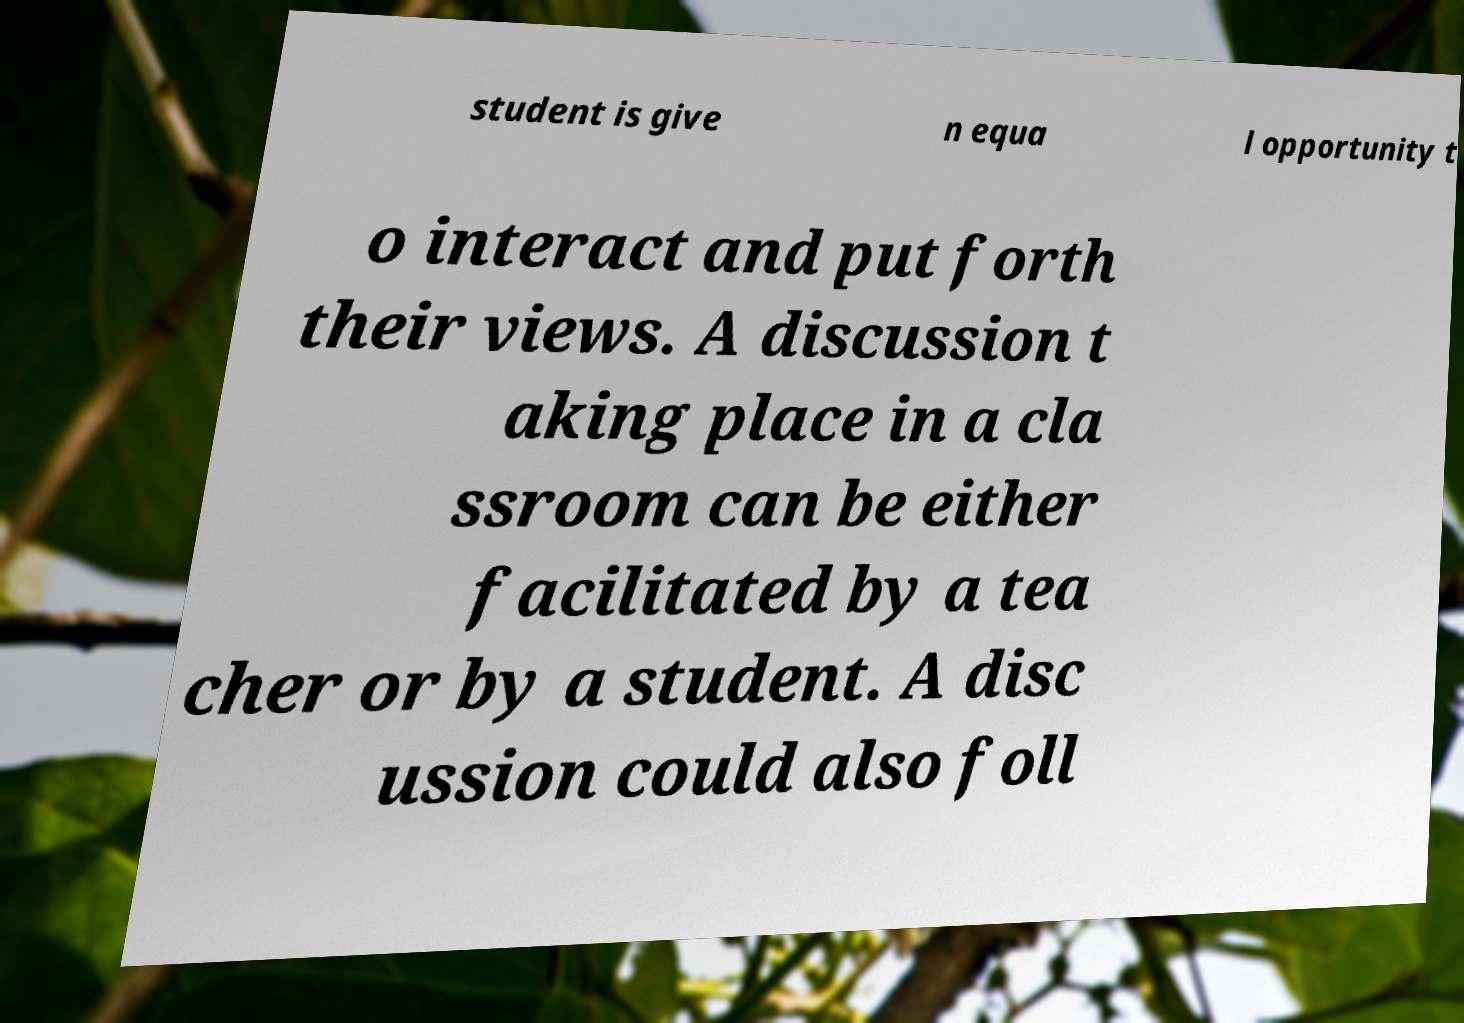What messages or text are displayed in this image? I need them in a readable, typed format. student is give n equa l opportunity t o interact and put forth their views. A discussion t aking place in a cla ssroom can be either facilitated by a tea cher or by a student. A disc ussion could also foll 